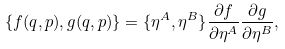Convert formula to latex. <formula><loc_0><loc_0><loc_500><loc_500>\{ f ( { q } , { p } ) , g ( { q } , { p } ) \} = \{ \eta ^ { A } , \eta ^ { B } \} \frac { \partial f } { \partial \eta ^ { A } } \frac { \partial g } { \partial \eta ^ { B } } ,</formula> 